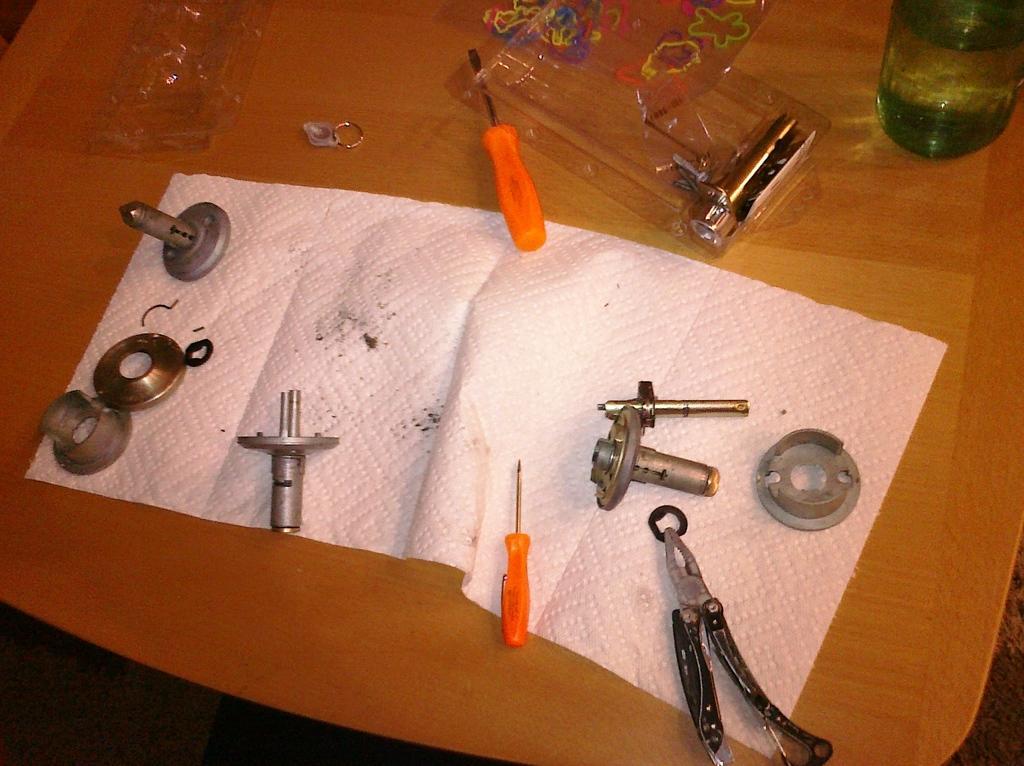In one or two sentences, can you explain what this image depicts? In this picture I can see screwdrivers, paper, bottle and some other tools and objects on the table. 